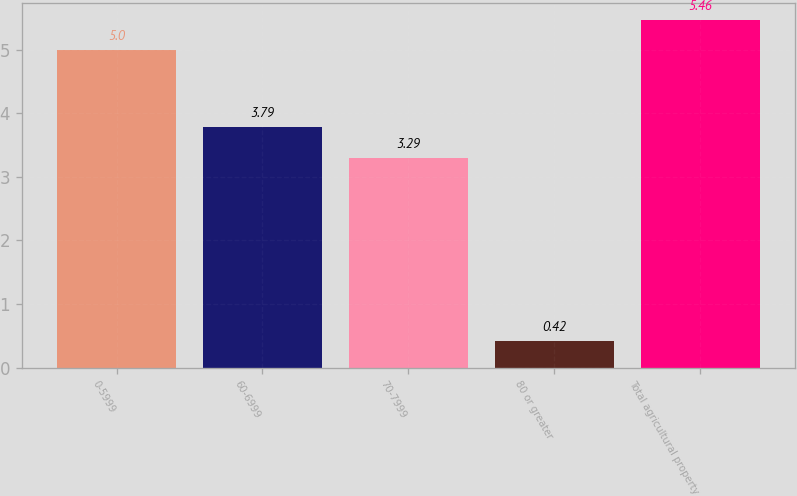Convert chart to OTSL. <chart><loc_0><loc_0><loc_500><loc_500><bar_chart><fcel>0-5999<fcel>60-6999<fcel>70-7999<fcel>80 or greater<fcel>Total agricultural property<nl><fcel>5<fcel>3.79<fcel>3.29<fcel>0.42<fcel>5.46<nl></chart> 